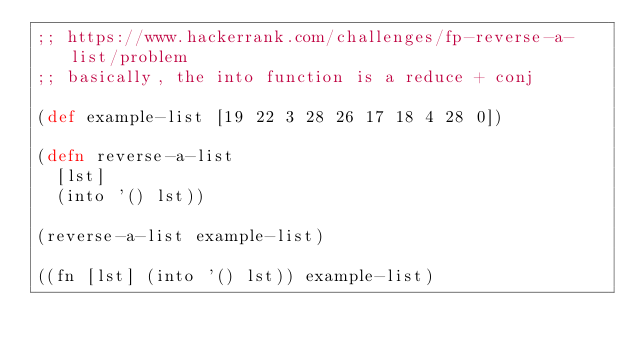Convert code to text. <code><loc_0><loc_0><loc_500><loc_500><_Clojure_>;; https://www.hackerrank.com/challenges/fp-reverse-a-list/problem
;; basically, the into function is a reduce + conj

(def example-list [19 22 3 28 26 17 18 4 28 0])

(defn reverse-a-list
  [lst]
  (into '() lst))

(reverse-a-list example-list)

((fn [lst] (into '() lst)) example-list)
</code> 